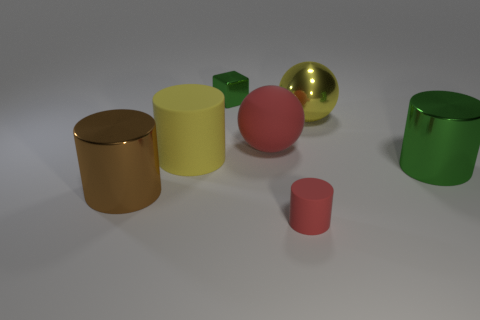Is the tiny matte cylinder the same color as the rubber ball?
Your answer should be very brief. Yes. Do the large cylinder that is right of the tiny red thing and the small metallic block have the same color?
Provide a short and direct response. Yes. Is there a large object of the same color as the small matte cylinder?
Your answer should be very brief. Yes. There is a brown metallic cylinder; what number of metal cylinders are behind it?
Give a very brief answer. 1. What number of other objects are the same size as the yellow cylinder?
Give a very brief answer. 4. Do the thing to the left of the large yellow matte cylinder and the big cylinder that is on the right side of the large yellow metal sphere have the same material?
Keep it short and to the point. Yes. What is the color of the rubber sphere that is the same size as the brown cylinder?
Make the answer very short. Red. Are there any other things that are the same color as the large metal ball?
Your answer should be compact. Yes. There is a matte cylinder behind the big cylinder that is right of the rubber thing to the left of the green block; what size is it?
Make the answer very short. Large. There is a large shiny object that is on the right side of the yellow cylinder and in front of the metal sphere; what is its color?
Offer a terse response. Green. 